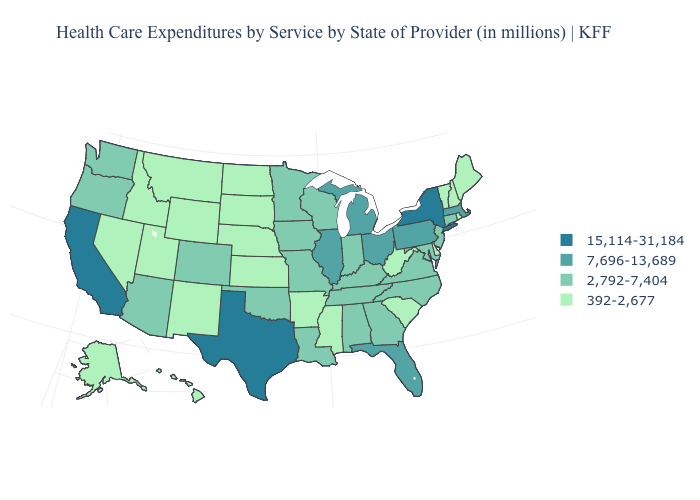Which states have the highest value in the USA?
Be succinct. California, New York, Texas. What is the value of Connecticut?
Quick response, please. 2,792-7,404. Name the states that have a value in the range 7,696-13,689?
Short answer required. Florida, Illinois, Massachusetts, Michigan, Ohio, Pennsylvania. What is the highest value in the USA?
Answer briefly. 15,114-31,184. What is the value of Wisconsin?
Answer briefly. 2,792-7,404. Is the legend a continuous bar?
Short answer required. No. What is the value of Mississippi?
Short answer required. 392-2,677. Among the states that border Utah , does Nevada have the highest value?
Give a very brief answer. No. Among the states that border Washington , which have the lowest value?
Quick response, please. Idaho. Name the states that have a value in the range 392-2,677?
Be succinct. Alaska, Arkansas, Delaware, Hawaii, Idaho, Kansas, Maine, Mississippi, Montana, Nebraska, Nevada, New Hampshire, New Mexico, North Dakota, Rhode Island, South Carolina, South Dakota, Utah, Vermont, West Virginia, Wyoming. Does Colorado have a higher value than New Hampshire?
Keep it brief. Yes. Does the first symbol in the legend represent the smallest category?
Be succinct. No. What is the value of Maryland?
Give a very brief answer. 2,792-7,404. Name the states that have a value in the range 15,114-31,184?
Give a very brief answer. California, New York, Texas. What is the highest value in the Northeast ?
Be succinct. 15,114-31,184. 